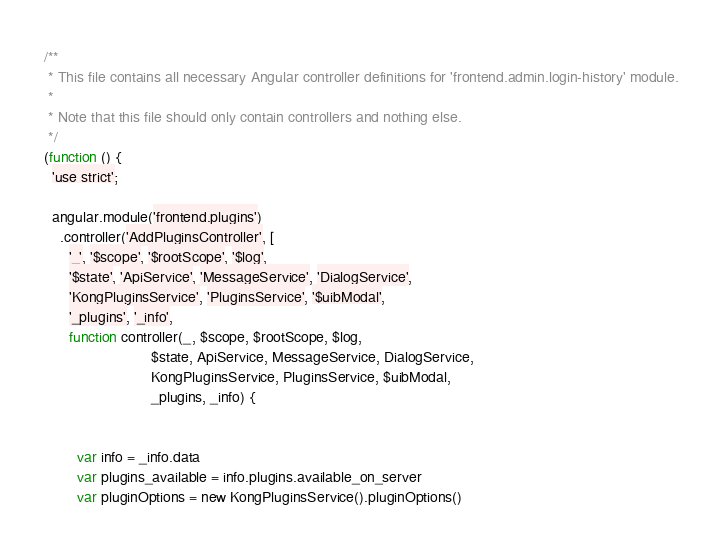<code> <loc_0><loc_0><loc_500><loc_500><_JavaScript_>/**
 * This file contains all necessary Angular controller definitions for 'frontend.admin.login-history' module.
 *
 * Note that this file should only contain controllers and nothing else.
 */
(function () {
  'use strict';

  angular.module('frontend.plugins')
    .controller('AddPluginsController', [
      '_', '$scope', '$rootScope', '$log',
      '$state', 'ApiService', 'MessageService', 'DialogService',
      'KongPluginsService', 'PluginsService', '$uibModal',
      '_plugins', '_info',
      function controller(_, $scope, $rootScope, $log,
                          $state, ApiService, MessageService, DialogService,
                          KongPluginsService, PluginsService, $uibModal,
                          _plugins, _info) {


        var info = _info.data
        var plugins_available = info.plugins.available_on_server
        var pluginOptions = new KongPluginsService().pluginOptions()
</code> 